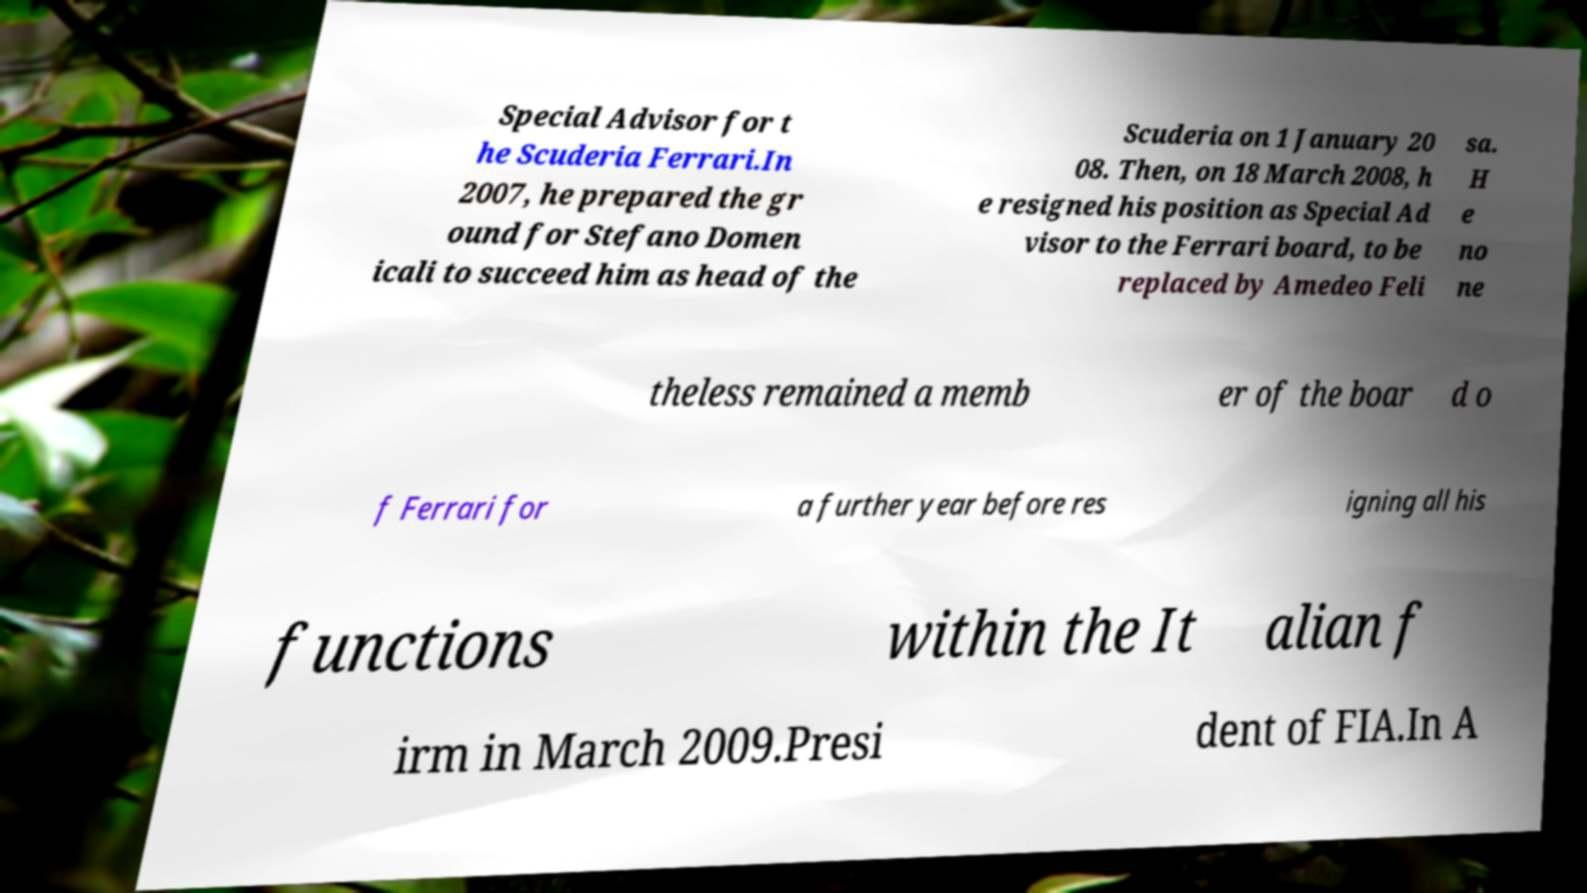Could you assist in decoding the text presented in this image and type it out clearly? Special Advisor for t he Scuderia Ferrari.In 2007, he prepared the gr ound for Stefano Domen icali to succeed him as head of the Scuderia on 1 January 20 08. Then, on 18 March 2008, h e resigned his position as Special Ad visor to the Ferrari board, to be replaced by Amedeo Feli sa. H e no ne theless remained a memb er of the boar d o f Ferrari for a further year before res igning all his functions within the It alian f irm in March 2009.Presi dent of FIA.In A 